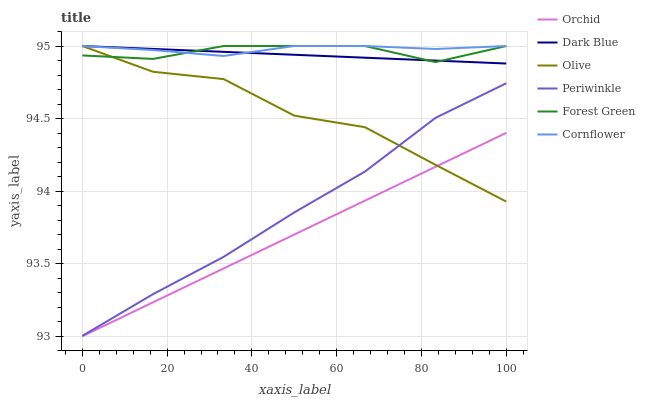Does Orchid have the minimum area under the curve?
Answer yes or no. Yes. Does Cornflower have the maximum area under the curve?
Answer yes or no. Yes. Does Dark Blue have the minimum area under the curve?
Answer yes or no. No. Does Dark Blue have the maximum area under the curve?
Answer yes or no. No. Is Dark Blue the smoothest?
Answer yes or no. Yes. Is Olive the roughest?
Answer yes or no. Yes. Is Forest Green the smoothest?
Answer yes or no. No. Is Forest Green the roughest?
Answer yes or no. No. Does Orchid have the lowest value?
Answer yes or no. Yes. Does Dark Blue have the lowest value?
Answer yes or no. No. Does Olive have the highest value?
Answer yes or no. Yes. Does Periwinkle have the highest value?
Answer yes or no. No. Is Orchid less than Forest Green?
Answer yes or no. Yes. Is Cornflower greater than Orchid?
Answer yes or no. Yes. Does Olive intersect Cornflower?
Answer yes or no. Yes. Is Olive less than Cornflower?
Answer yes or no. No. Is Olive greater than Cornflower?
Answer yes or no. No. Does Orchid intersect Forest Green?
Answer yes or no. No. 